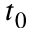<formula> <loc_0><loc_0><loc_500><loc_500>t _ { 0 }</formula> 